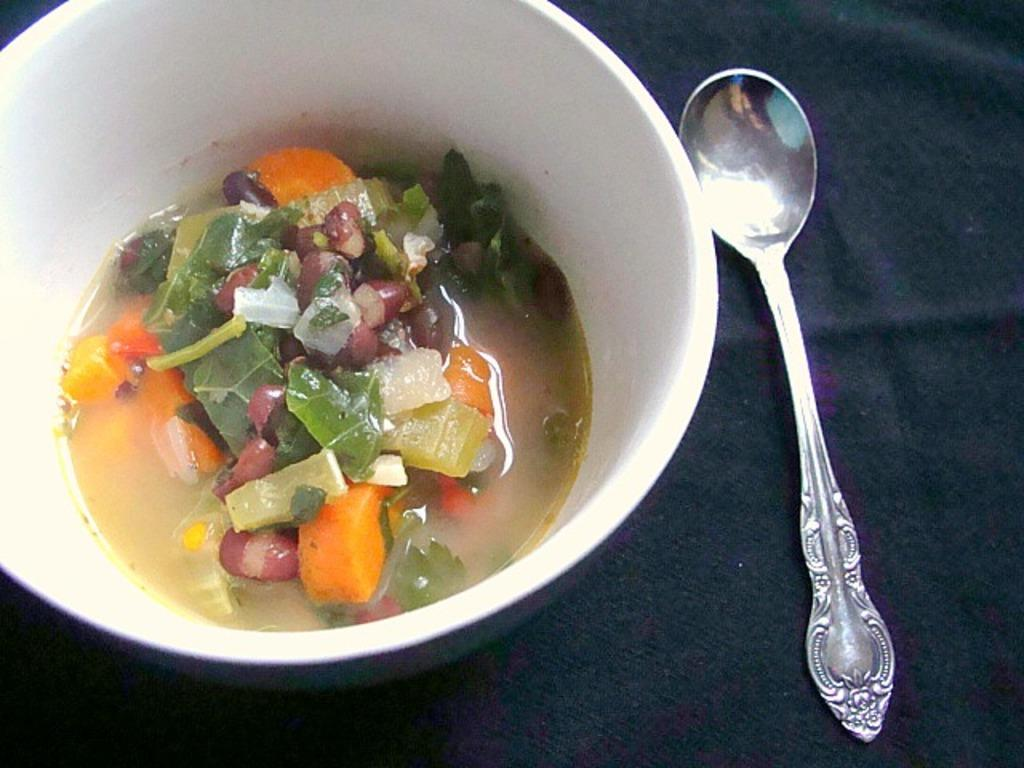What is in the bowl that is visible in the image? There is food in a bowl in the image. What utensil is placed beside the bowl in the image? There is a spoon beside the bowl in the image. What is the bowl and spoon placed on in the image? The bowl and spoon are on a cloth. What type of lamp is present at the event in the image? There is no lamp or event present in the image; it only features a bowl of food, a spoon, and a cloth. What government policy is being discussed in the image? There is no discussion or mention of government policies in the image. 